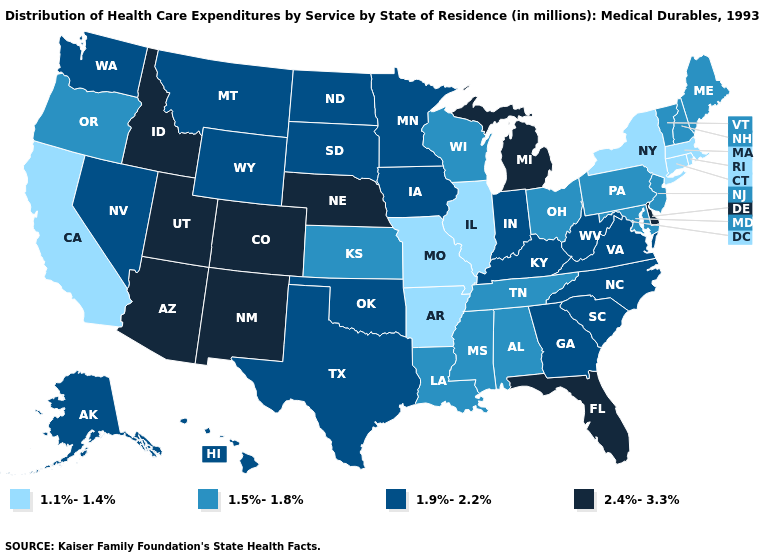Name the states that have a value in the range 1.5%-1.8%?
Write a very short answer. Alabama, Kansas, Louisiana, Maine, Maryland, Mississippi, New Hampshire, New Jersey, Ohio, Oregon, Pennsylvania, Tennessee, Vermont, Wisconsin. Name the states that have a value in the range 2.4%-3.3%?
Answer briefly. Arizona, Colorado, Delaware, Florida, Idaho, Michigan, Nebraska, New Mexico, Utah. What is the highest value in the USA?
Give a very brief answer. 2.4%-3.3%. Does Alabama have the same value as Pennsylvania?
Write a very short answer. Yes. What is the lowest value in the USA?
Quick response, please. 1.1%-1.4%. What is the value of New York?
Be succinct. 1.1%-1.4%. What is the value of Delaware?
Write a very short answer. 2.4%-3.3%. Does the map have missing data?
Be succinct. No. Name the states that have a value in the range 1.5%-1.8%?
Write a very short answer. Alabama, Kansas, Louisiana, Maine, Maryland, Mississippi, New Hampshire, New Jersey, Ohio, Oregon, Pennsylvania, Tennessee, Vermont, Wisconsin. What is the value of Wisconsin?
Answer briefly. 1.5%-1.8%. Which states have the lowest value in the USA?
Keep it brief. Arkansas, California, Connecticut, Illinois, Massachusetts, Missouri, New York, Rhode Island. What is the value of Kentucky?
Keep it brief. 1.9%-2.2%. Among the states that border Nevada , which have the highest value?
Keep it brief. Arizona, Idaho, Utah. Does New Hampshire have the highest value in the Northeast?
Write a very short answer. Yes. 